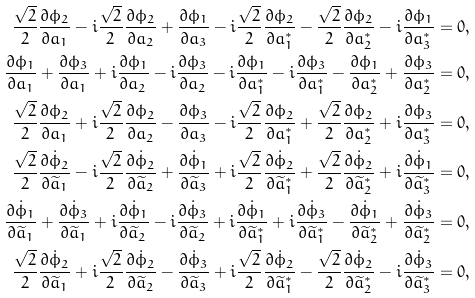<formula> <loc_0><loc_0><loc_500><loc_500>\frac { \sqrt { 2 } } { 2 } \frac { \partial \phi _ { 2 } } { \partial a _ { 1 } } - i \frac { \sqrt { 2 } } { 2 } \frac { \partial \phi _ { 2 } } { \partial a _ { 2 } } + \frac { \partial \phi _ { 1 } } { \partial a _ { 3 } } - i \frac { \sqrt { 2 } } { 2 } \frac { \partial \phi _ { 2 } } { \partial a ^ { \ast } _ { 1 } } - \frac { \sqrt { 2 } } { 2 } \frac { \partial \phi _ { 2 } } { \partial a ^ { \ast } _ { 2 } } - i \frac { \partial \phi _ { 1 } } { \partial a ^ { \ast } _ { 3 } } = 0 , \\ \frac { \partial \phi _ { 1 } } { \partial a _ { 1 } } + \frac { \partial \phi _ { 3 } } { \partial a _ { 1 } } + i \frac { \partial \phi _ { 1 } } { \partial a _ { 2 } } - i \frac { \partial \phi _ { 3 } } { \partial a _ { 2 } } - i \frac { \partial \phi _ { 1 } } { \partial a ^ { \ast } _ { 1 } } - i \frac { \partial \phi _ { 3 } } { \partial a ^ { \ast } _ { 1 } } - \frac { \partial \phi _ { 1 } } { \partial a ^ { \ast } _ { 2 } } + \frac { \partial \phi _ { 3 } } { \partial a ^ { \ast } _ { 2 } } = 0 , \\ \frac { \sqrt { 2 } } { 2 } \frac { \partial \phi _ { 2 } } { \partial a _ { 1 } } + i \frac { \sqrt { 2 } } { 2 } \frac { \partial \phi _ { 2 } } { \partial a _ { 2 } } - \frac { \partial \phi _ { 3 } } { \partial a _ { 3 } } - i \frac { \sqrt { 2 } } { 2 } \frac { \partial \phi _ { 2 } } { \partial a ^ { \ast } _ { 1 } } + \frac { \sqrt { 2 } } { 2 } \frac { \partial \phi _ { 2 } } { \partial a ^ { \ast } _ { 2 } } + i \frac { \partial \phi _ { 3 } } { \partial a ^ { \ast } _ { 3 } } = 0 , \\ \frac { \sqrt { 2 } } { 2 } \frac { \partial \dot { \phi } _ { 2 } } { \partial \widetilde { a } _ { 1 } } - i \frac { \sqrt { 2 } } { 2 } \frac { \partial \dot { \phi } _ { 2 } } { \partial \widetilde { a } _ { 2 } } + \frac { \partial \dot { \phi } _ { 1 } } { \partial \widetilde { a } _ { 3 } } + i \frac { \sqrt { 2 } } { 2 } \frac { \partial \dot { \phi } _ { 2 } } { \partial \widetilde { a } ^ { \ast } _ { 1 } } + \frac { \sqrt { 2 } } { 2 } \frac { \partial \dot { \phi } _ { 2 } } { \partial \widetilde { a } ^ { \ast } _ { 2 } } + i \frac { \partial \dot { \phi } _ { 1 } } { \partial \widetilde { a } ^ { \ast } _ { 3 } } = 0 , \\ \frac { \partial \dot { \phi } _ { 1 } } { \partial \widetilde { a } _ { 1 } } + \frac { \partial \dot { \phi } _ { 3 } } { \partial \widetilde { a } _ { 1 } } + i \frac { \partial \dot { \phi } _ { 1 } } { \partial \widetilde { a } _ { 2 } } - i \frac { \partial \dot { \phi } _ { 3 } } { \partial \widetilde { a } _ { 2 } } + i \frac { \partial \dot { \phi } _ { 1 } } { \partial \widetilde { a } ^ { \ast } _ { 1 } } + i \frac { \partial \dot { \phi } _ { 3 } } { \partial \widetilde { a } ^ { \ast } _ { 1 } } - \frac { \partial \dot { \phi } _ { 1 } } { \partial \widetilde { a } ^ { \ast } _ { 2 } } + \frac { \partial \dot { \phi } _ { 3 } } { \partial \widetilde { a } ^ { \ast } _ { 2 } } = 0 , \\ \frac { \sqrt { 2 } } { 2 } \frac { \partial \dot { \phi } _ { 2 } } { \partial \widetilde { a } _ { 1 } } + i \frac { \sqrt { 2 } } { 2 } \frac { \partial \dot { \phi } _ { 2 } } { \partial \widetilde { a } _ { 2 } } - \frac { \partial \dot { \phi } _ { 3 } } { \partial \widetilde { a } _ { 3 } } + i \frac { \sqrt { 2 } } { 2 } \frac { \partial \dot { \phi } _ { 2 } } { \partial \widetilde { a } ^ { \ast } _ { 1 } } - \frac { \sqrt { 2 } } { 2 } \frac { \partial \dot { \phi } _ { 2 } } { \partial \widetilde { a } ^ { \ast } _ { 2 } } - i \frac { \partial \dot { \phi } _ { 3 } } { \partial \widetilde { a } ^ { \ast } _ { 3 } } = 0 ,</formula> 